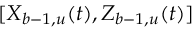<formula> <loc_0><loc_0><loc_500><loc_500>[ X _ { b - 1 , u } ( t ) , Z _ { b - 1 , u } ( t ) ]</formula> 